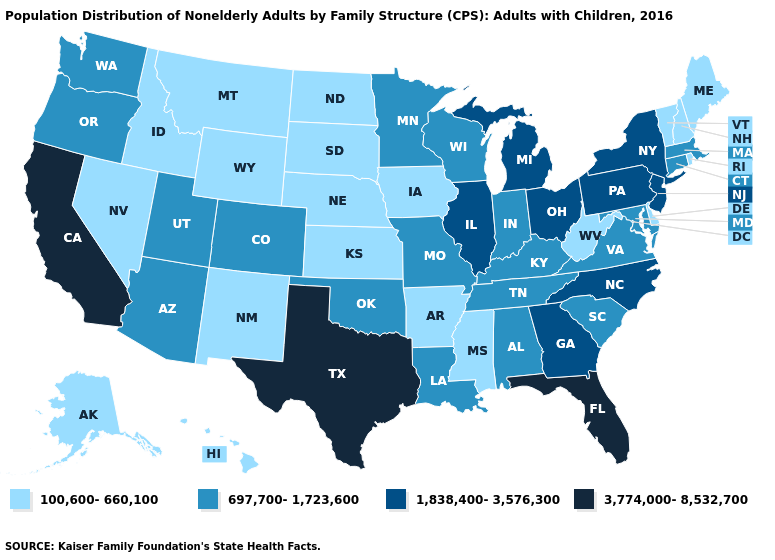Does Florida have the highest value in the South?
Quick response, please. Yes. Which states hav the highest value in the MidWest?
Concise answer only. Illinois, Michigan, Ohio. Name the states that have a value in the range 3,774,000-8,532,700?
Be succinct. California, Florida, Texas. What is the highest value in the Northeast ?
Short answer required. 1,838,400-3,576,300. What is the value of Arkansas?
Write a very short answer. 100,600-660,100. Which states have the lowest value in the USA?
Write a very short answer. Alaska, Arkansas, Delaware, Hawaii, Idaho, Iowa, Kansas, Maine, Mississippi, Montana, Nebraska, Nevada, New Hampshire, New Mexico, North Dakota, Rhode Island, South Dakota, Vermont, West Virginia, Wyoming. What is the highest value in the MidWest ?
Quick response, please. 1,838,400-3,576,300. Does Delaware have a lower value than Michigan?
Be succinct. Yes. What is the value of Connecticut?
Answer briefly. 697,700-1,723,600. Name the states that have a value in the range 3,774,000-8,532,700?
Write a very short answer. California, Florida, Texas. Does Alabama have a lower value than North Carolina?
Keep it brief. Yes. What is the value of Kentucky?
Keep it brief. 697,700-1,723,600. What is the highest value in the USA?
Quick response, please. 3,774,000-8,532,700. Among the states that border New Hampshire , which have the lowest value?
Concise answer only. Maine, Vermont. What is the value of Oregon?
Concise answer only. 697,700-1,723,600. 